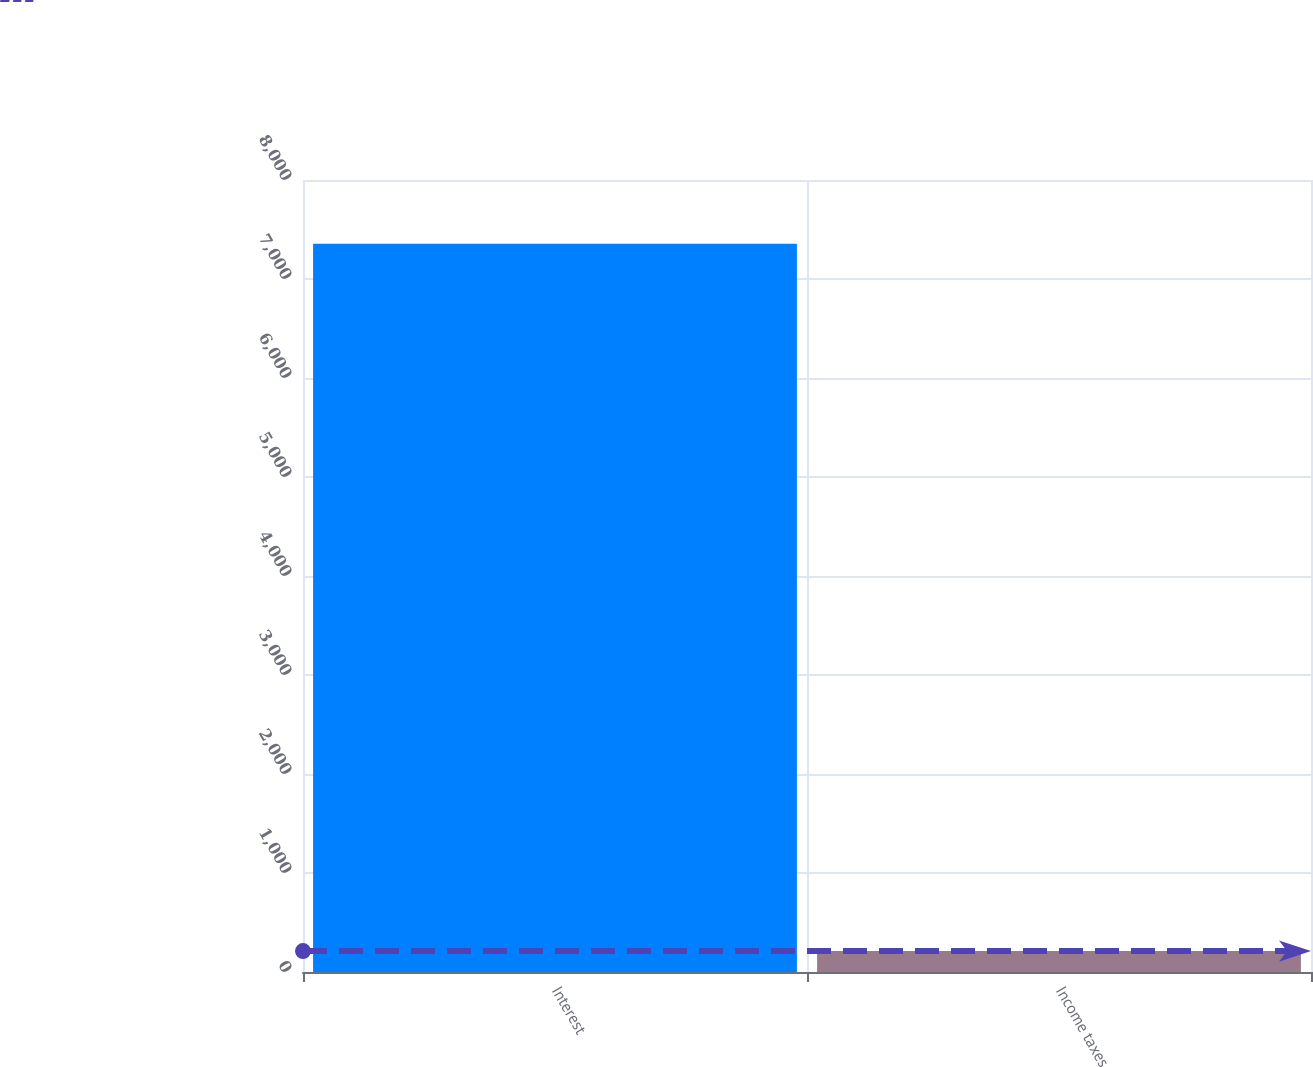Convert chart. <chart><loc_0><loc_0><loc_500><loc_500><bar_chart><fcel>Interest<fcel>Income taxes<nl><fcel>7355<fcel>211<nl></chart> 